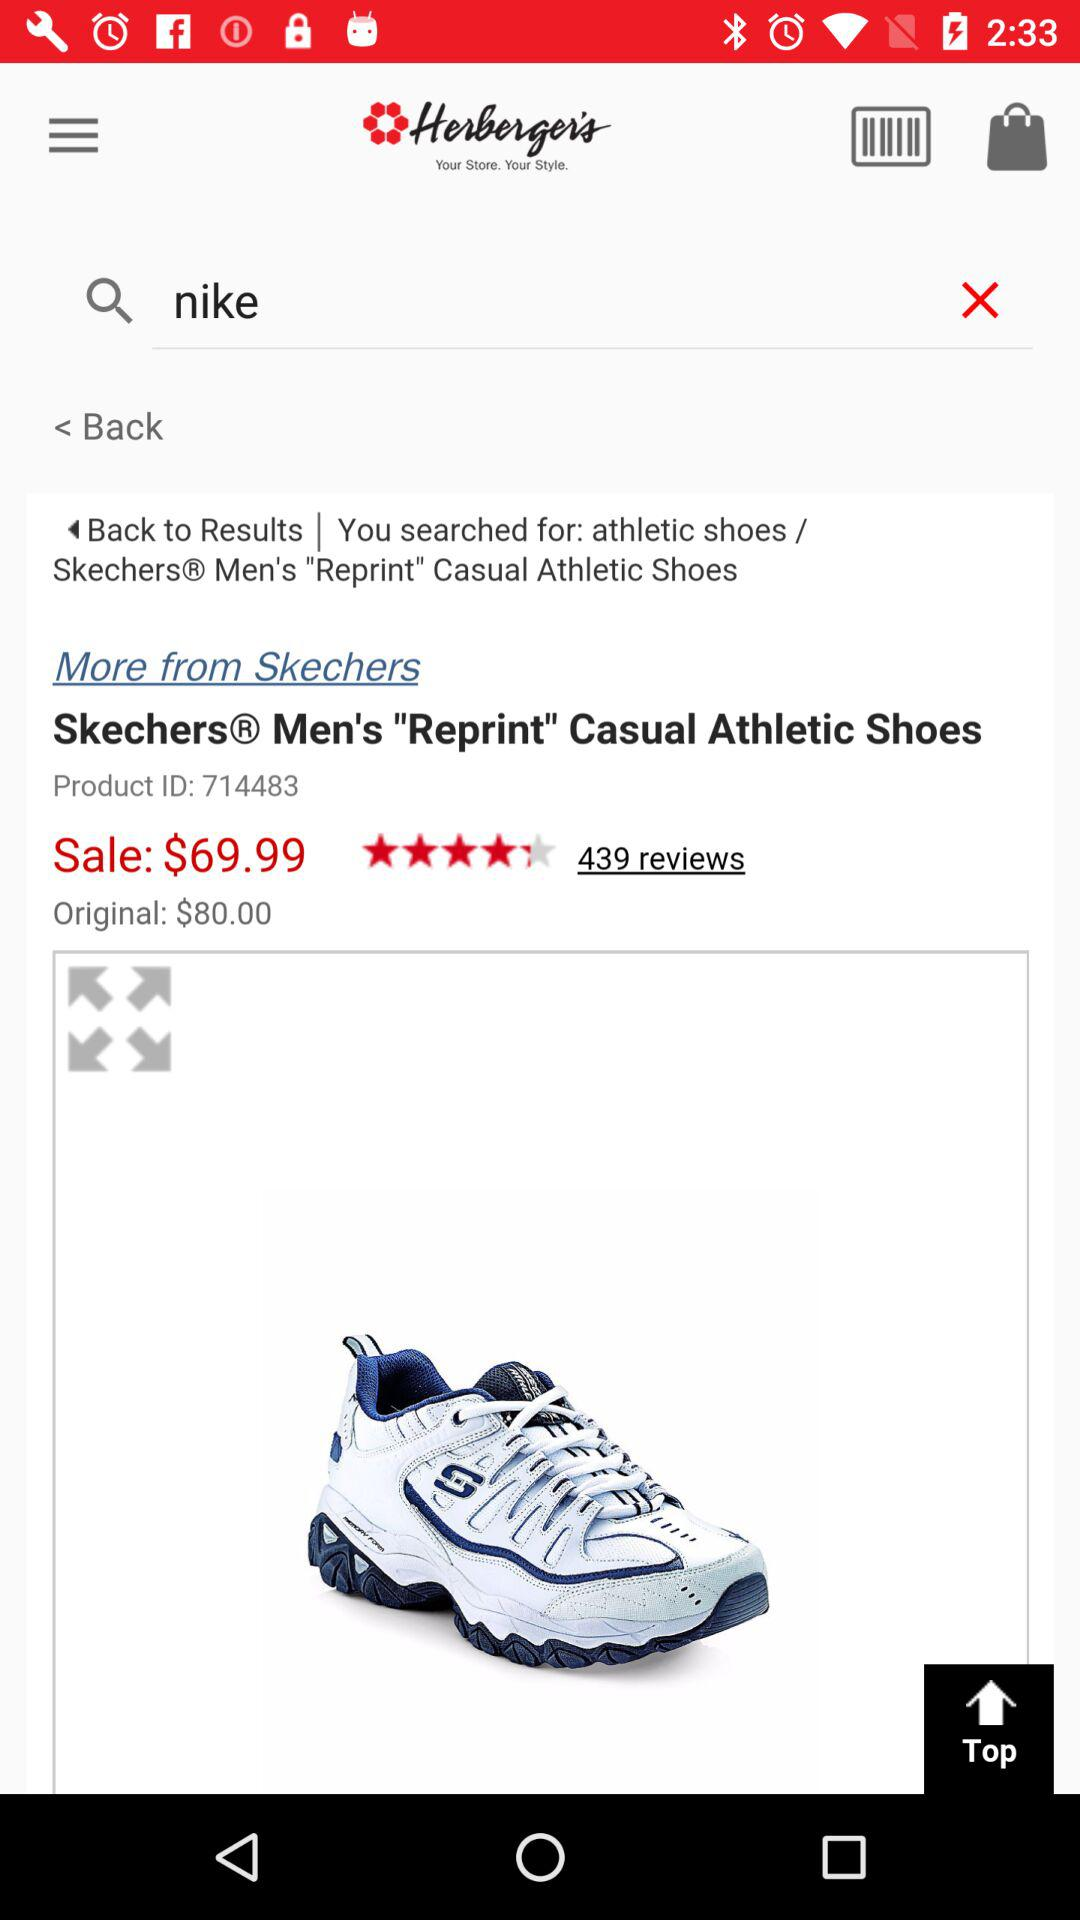How much is the original price of the product?
Answer the question using a single word or phrase. $80.00 